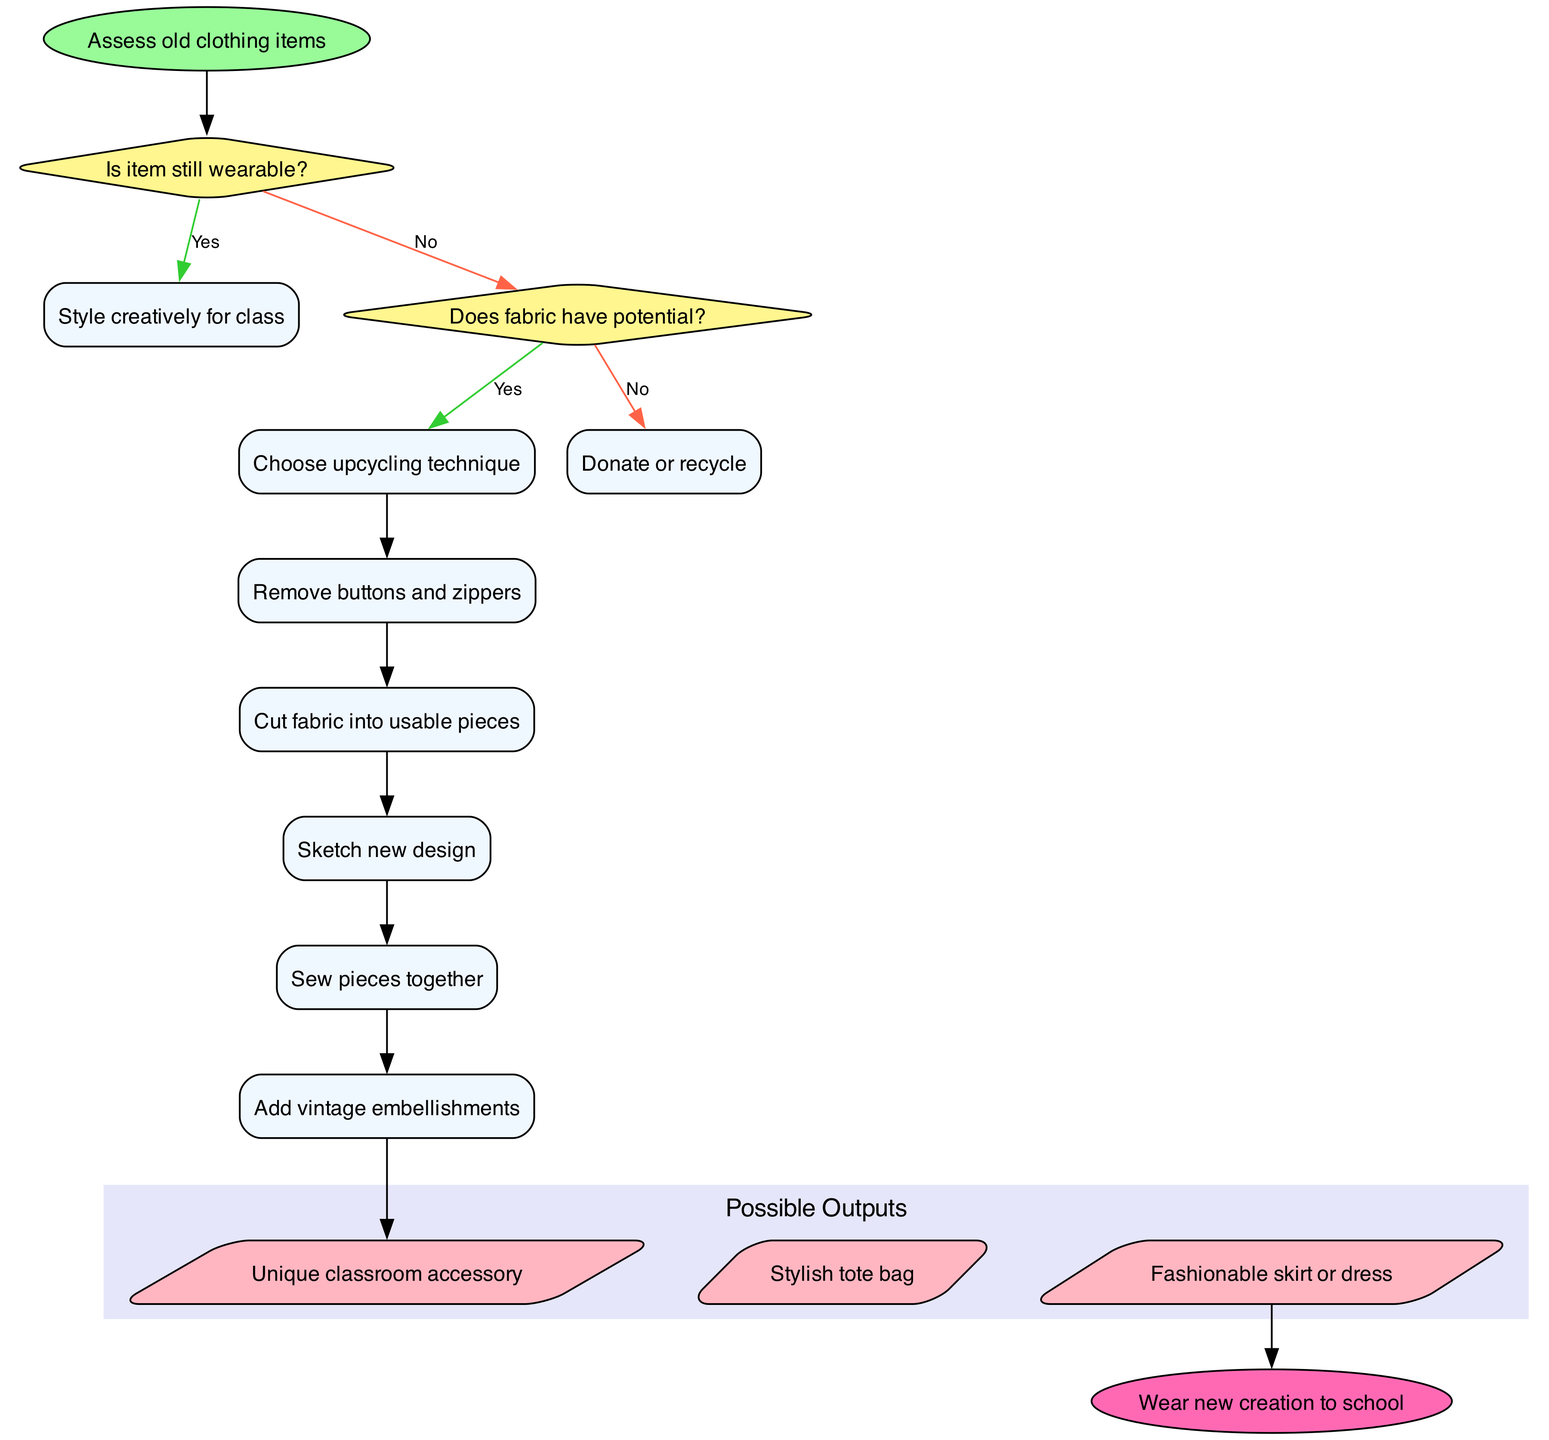What's the first step in the process? The diagram indicates that the first step is "Assess old clothing items," which is shown as the starting point of the flowchart.
Answer: Assess old clothing items How many decision nodes are present in the diagram? The diagram has two decision nodes, as seen in the structure where decisions are made based on the conditions specified.
Answer: 2 What happens if the fabric does not have potential? The flowchart shows that "Donate or recycle" is the outcome if the fabric doesn't have potential, following the decision under that specific condition.
Answer: Donate or recycle What is the output of the flowchart after the processing steps? Upon reviewing the outputs, the final outputs listed are "Unique classroom accessory," "Stylish tote bag," and "Fashionable skirt or dress," indicating the results after processing.
Answer: Unique classroom accessory, Stylish tote bag, Fashionable skirt or dress What occurs after sewing the pieces together? According to the flowchart, after "Sew pieces together," the next step in the process is "Add vintage embellishments."
Answer: Add vintage embellishments What is the final outcome represented in the diagram? The last node connected to the flowchart is labeled "Wear new creation to school," indicating the ultimate goal after completing all previous steps.
Answer: Wear new creation to school What is the color of the start node? The start node is colored light green, as indicated in the flowchart specifications for the start section.
Answer: Light green How does the flow proceed if the item is still wearable? If the item is wearable, the flowchart indicates that it leads directly to "Style creatively for class," which is the subsequent step after that decision.
Answer: Style creatively for class What is the purpose of removing buttons and zippers? The flowchart lists "Remove buttons and zippers" as an initial process step, suggesting the intention is to prep the fabric for upcycling.
Answer: Prep the fabric for upcycling 